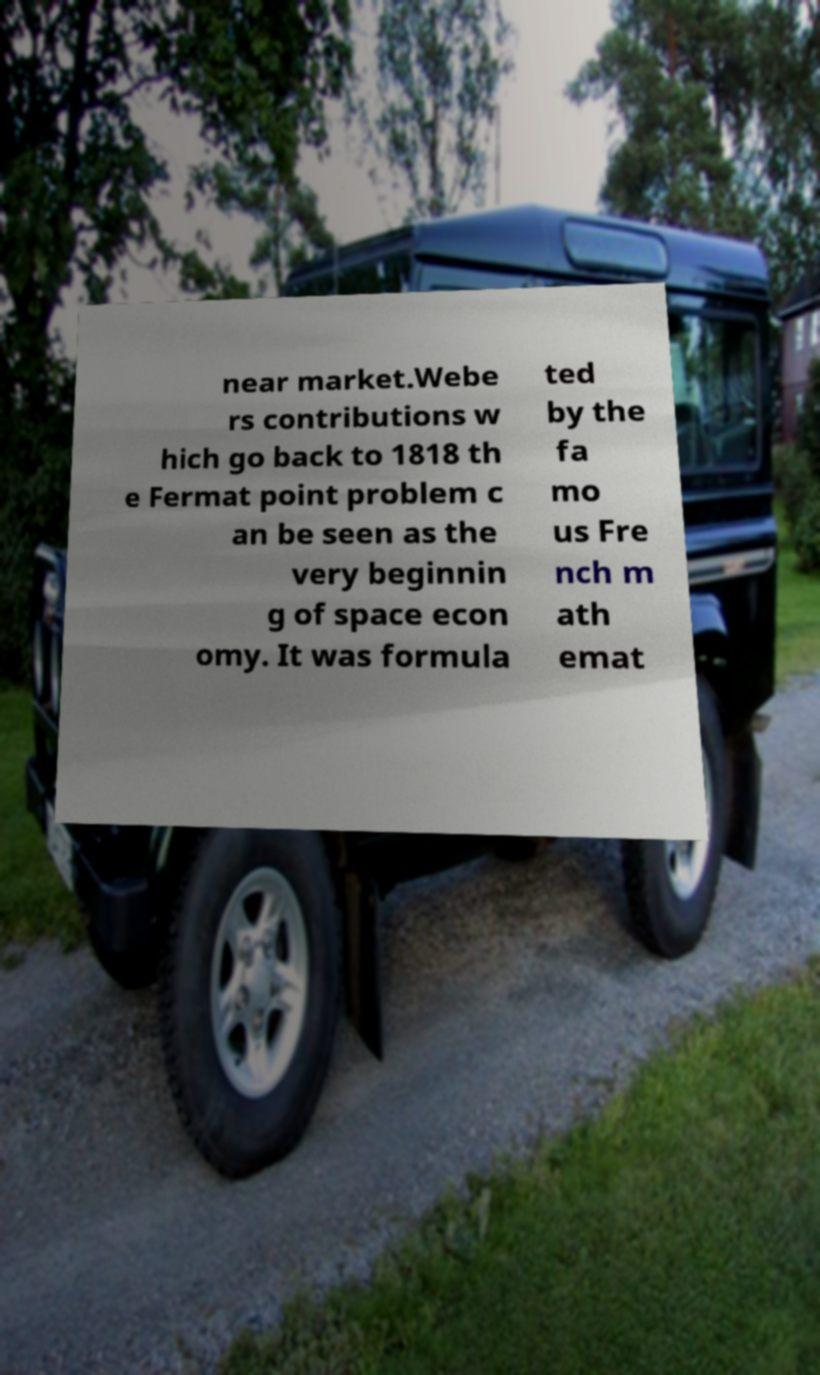I need the written content from this picture converted into text. Can you do that? near market.Webe rs contributions w hich go back to 1818 th e Fermat point problem c an be seen as the very beginnin g of space econ omy. It was formula ted by the fa mo us Fre nch m ath emat 